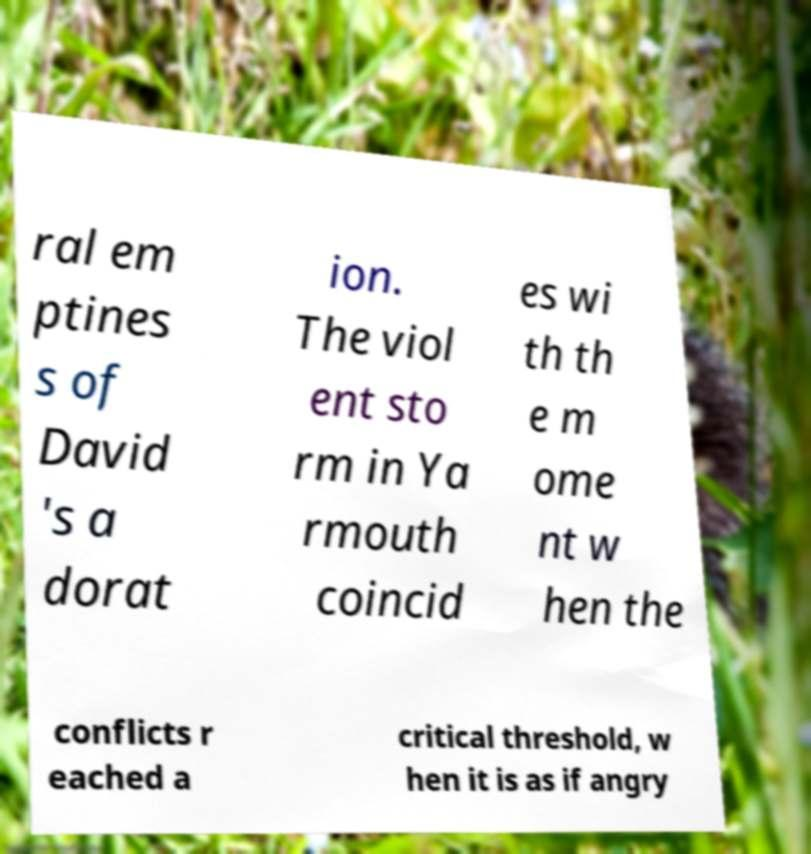Could you extract and type out the text from this image? ral em ptines s of David 's a dorat ion. The viol ent sto rm in Ya rmouth coincid es wi th th e m ome nt w hen the conflicts r eached a critical threshold, w hen it is as if angry 